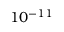Convert formula to latex. <formula><loc_0><loc_0><loc_500><loc_500>1 0 ^ { - 1 1 }</formula> 